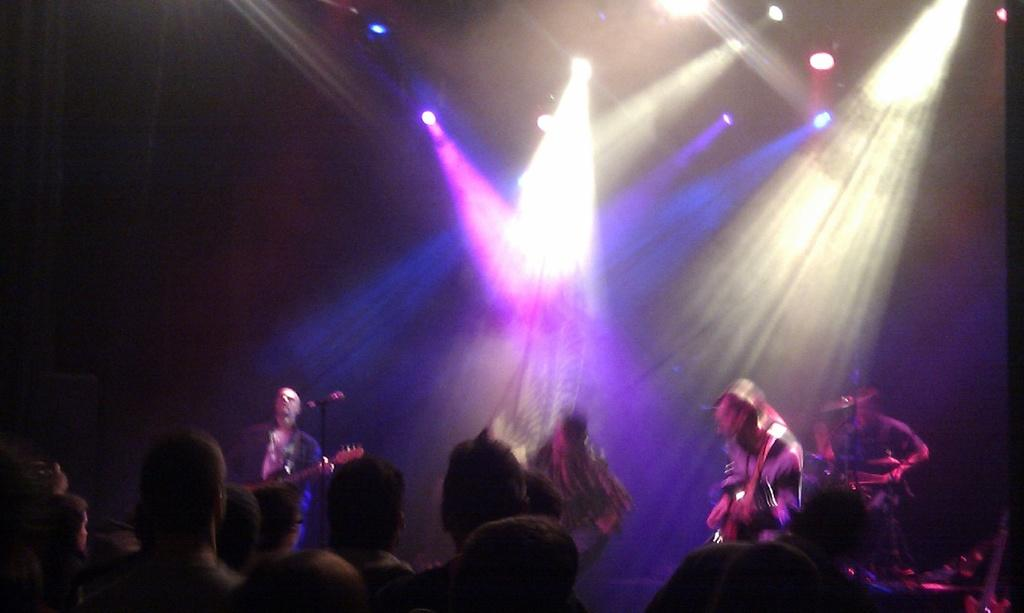What are the people on the stage doing? The people on stage are playing musical instruments. What can be seen on the stage besides the musicians? There is a microphone on the stage. Who is present in the image besides the musicians on stage? There is an audience in the image. What can be seen in the image that might be used for illumination? There are lights visible in the image. How many cushions are being used by the audience in the image? There is no mention of cushions in the image, so we cannot determine how many are being used by the audience. What type of war is being depicted in the image? There is no depiction of war in the image; it features people playing musical instruments on stage with an audience. 